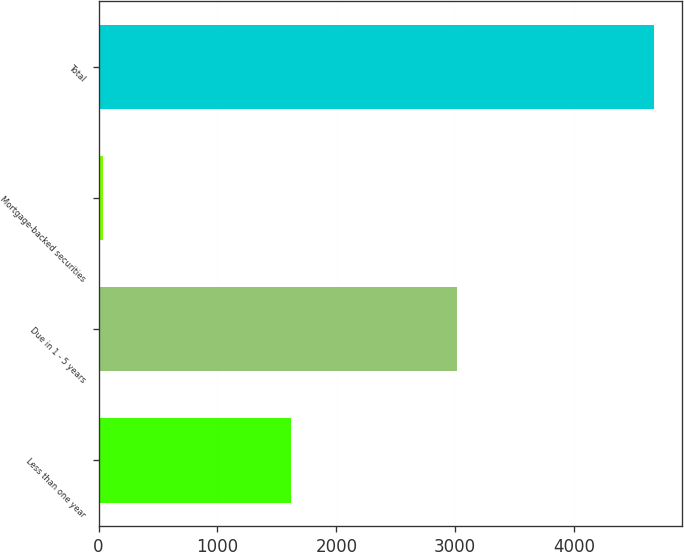<chart> <loc_0><loc_0><loc_500><loc_500><bar_chart><fcel>Less than one year<fcel>Due in 1 - 5 years<fcel>Mortgage-backed securities<fcel>Total<nl><fcel>1619<fcel>3019<fcel>34<fcel>4672<nl></chart> 